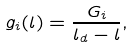Convert formula to latex. <formula><loc_0><loc_0><loc_500><loc_500>g _ { i } ( l ) = \frac { G _ { i } } { l _ { d } - l } ,</formula> 